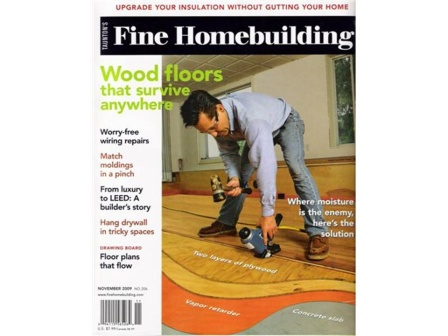What skills does the man on the magazine cover likely possess? The man on the magazine cover likely possesses skills in carpentry and floor installation, as evidenced by his focus on working with the wooden floor and the hammer in his hand. Additionally, considering the various topics featured on the cover such as wiring repairs, molding matches, and drywall hanging, he might also have knowledge and experience in those areas, making him a versatile and skilled handyman. How might the practical advice in this magazine be beneficial to a new homeowner? The practical advice in this magazine can be incredibly beneficial to a new homeowner by providing them with the necessary knowledge and skills to handle common home maintenance and renovation tasks. Tips on ensuring wood floors survive anywhere, making wiring repairs, matching moldings, hanging drywall in tricky spaces, and handling moisture problems can empower a new homeowner to make informed decisions, save money on hiring professionals, and maintain their home more effectively. 